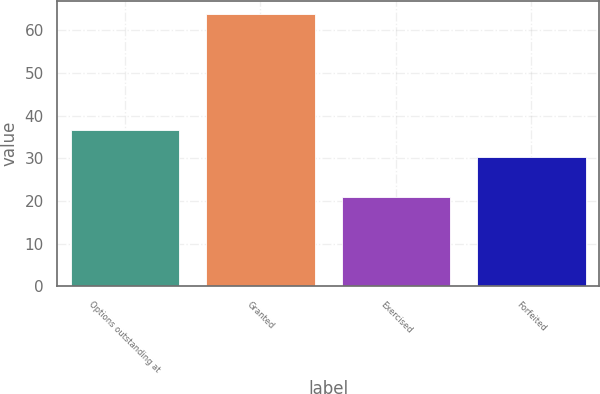Convert chart to OTSL. <chart><loc_0><loc_0><loc_500><loc_500><bar_chart><fcel>Options outstanding at<fcel>Granted<fcel>Exercised<fcel>Forfeited<nl><fcel>36.68<fcel>63.79<fcel>20.9<fcel>30.41<nl></chart> 